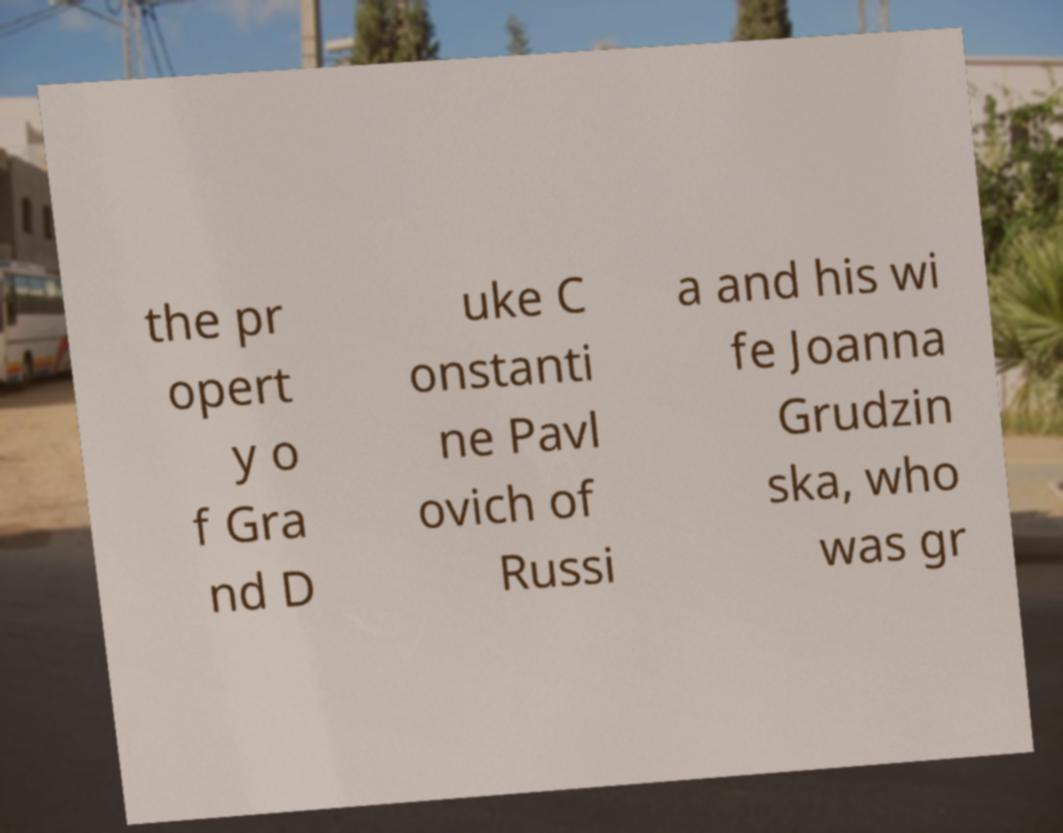Please identify and transcribe the text found in this image. the pr opert y o f Gra nd D uke C onstanti ne Pavl ovich of Russi a and his wi fe Joanna Grudzin ska, who was gr 